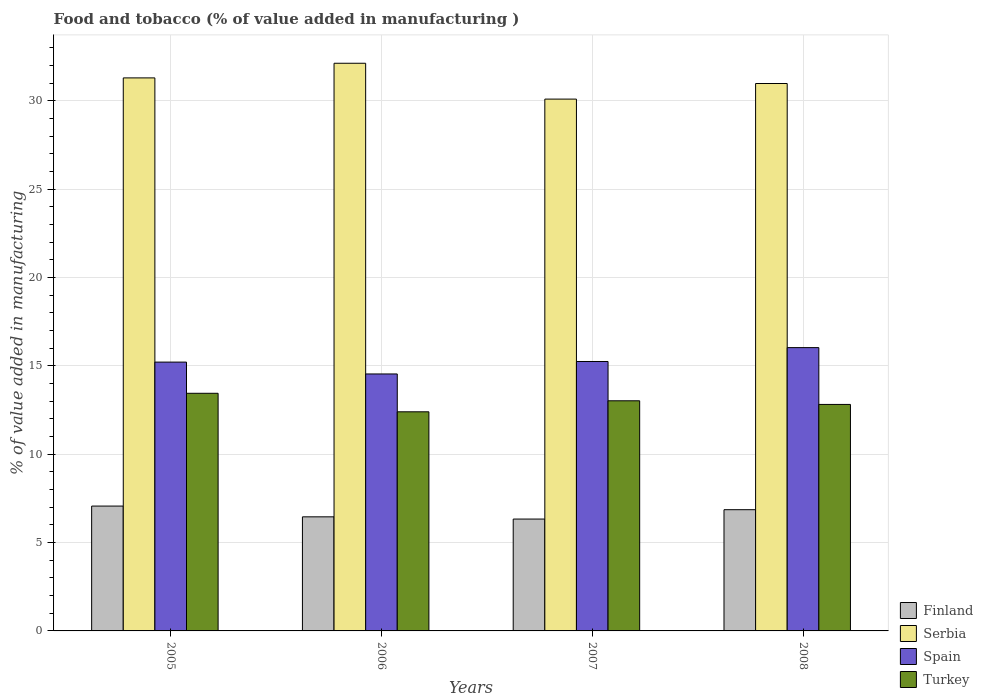Are the number of bars per tick equal to the number of legend labels?
Provide a short and direct response. Yes. Are the number of bars on each tick of the X-axis equal?
Provide a succinct answer. Yes. How many bars are there on the 2nd tick from the left?
Your response must be concise. 4. How many bars are there on the 1st tick from the right?
Keep it short and to the point. 4. What is the value added in manufacturing food and tobacco in Turkey in 2007?
Offer a terse response. 13.02. Across all years, what is the maximum value added in manufacturing food and tobacco in Turkey?
Provide a succinct answer. 13.45. Across all years, what is the minimum value added in manufacturing food and tobacco in Spain?
Your response must be concise. 14.54. In which year was the value added in manufacturing food and tobacco in Finland maximum?
Your answer should be compact. 2005. What is the total value added in manufacturing food and tobacco in Turkey in the graph?
Offer a very short reply. 51.68. What is the difference between the value added in manufacturing food and tobacco in Serbia in 2006 and that in 2008?
Give a very brief answer. 1.15. What is the difference between the value added in manufacturing food and tobacco in Spain in 2008 and the value added in manufacturing food and tobacco in Finland in 2006?
Ensure brevity in your answer.  9.57. What is the average value added in manufacturing food and tobacco in Spain per year?
Your answer should be very brief. 15.26. In the year 2005, what is the difference between the value added in manufacturing food and tobacco in Turkey and value added in manufacturing food and tobacco in Spain?
Ensure brevity in your answer.  -1.76. In how many years, is the value added in manufacturing food and tobacco in Serbia greater than 1 %?
Your answer should be very brief. 4. What is the ratio of the value added in manufacturing food and tobacco in Finland in 2006 to that in 2007?
Your answer should be compact. 1.02. Is the value added in manufacturing food and tobacco in Serbia in 2006 less than that in 2007?
Your answer should be very brief. No. What is the difference between the highest and the second highest value added in manufacturing food and tobacco in Turkey?
Offer a terse response. 0.42. What is the difference between the highest and the lowest value added in manufacturing food and tobacco in Serbia?
Offer a terse response. 2.03. What does the 2nd bar from the left in 2007 represents?
Keep it short and to the point. Serbia. Is it the case that in every year, the sum of the value added in manufacturing food and tobacco in Finland and value added in manufacturing food and tobacco in Turkey is greater than the value added in manufacturing food and tobacco in Spain?
Make the answer very short. Yes. Are all the bars in the graph horizontal?
Provide a succinct answer. No. How many years are there in the graph?
Your answer should be compact. 4. Does the graph contain any zero values?
Keep it short and to the point. No. Does the graph contain grids?
Your answer should be compact. Yes. Where does the legend appear in the graph?
Your response must be concise. Bottom right. How many legend labels are there?
Provide a short and direct response. 4. How are the legend labels stacked?
Your response must be concise. Vertical. What is the title of the graph?
Offer a very short reply. Food and tobacco (% of value added in manufacturing ). Does "Cameroon" appear as one of the legend labels in the graph?
Your response must be concise. No. What is the label or title of the Y-axis?
Provide a short and direct response. % of value added in manufacturing. What is the % of value added in manufacturing of Finland in 2005?
Make the answer very short. 7.06. What is the % of value added in manufacturing in Serbia in 2005?
Your answer should be very brief. 31.29. What is the % of value added in manufacturing in Spain in 2005?
Offer a terse response. 15.21. What is the % of value added in manufacturing in Turkey in 2005?
Provide a short and direct response. 13.45. What is the % of value added in manufacturing in Finland in 2006?
Provide a short and direct response. 6.46. What is the % of value added in manufacturing in Serbia in 2006?
Ensure brevity in your answer.  32.12. What is the % of value added in manufacturing of Spain in 2006?
Your response must be concise. 14.54. What is the % of value added in manufacturing in Turkey in 2006?
Offer a terse response. 12.4. What is the % of value added in manufacturing in Finland in 2007?
Give a very brief answer. 6.33. What is the % of value added in manufacturing in Serbia in 2007?
Provide a short and direct response. 30.09. What is the % of value added in manufacturing of Spain in 2007?
Keep it short and to the point. 15.25. What is the % of value added in manufacturing of Turkey in 2007?
Make the answer very short. 13.02. What is the % of value added in manufacturing of Finland in 2008?
Provide a short and direct response. 6.86. What is the % of value added in manufacturing in Serbia in 2008?
Provide a short and direct response. 30.97. What is the % of value added in manufacturing in Spain in 2008?
Ensure brevity in your answer.  16.03. What is the % of value added in manufacturing in Turkey in 2008?
Give a very brief answer. 12.82. Across all years, what is the maximum % of value added in manufacturing in Finland?
Provide a short and direct response. 7.06. Across all years, what is the maximum % of value added in manufacturing of Serbia?
Your response must be concise. 32.12. Across all years, what is the maximum % of value added in manufacturing of Spain?
Your response must be concise. 16.03. Across all years, what is the maximum % of value added in manufacturing in Turkey?
Your response must be concise. 13.45. Across all years, what is the minimum % of value added in manufacturing of Finland?
Make the answer very short. 6.33. Across all years, what is the minimum % of value added in manufacturing of Serbia?
Make the answer very short. 30.09. Across all years, what is the minimum % of value added in manufacturing in Spain?
Ensure brevity in your answer.  14.54. Across all years, what is the minimum % of value added in manufacturing of Turkey?
Your answer should be very brief. 12.4. What is the total % of value added in manufacturing in Finland in the graph?
Offer a terse response. 26.71. What is the total % of value added in manufacturing in Serbia in the graph?
Offer a very short reply. 124.48. What is the total % of value added in manufacturing of Spain in the graph?
Provide a succinct answer. 61.03. What is the total % of value added in manufacturing of Turkey in the graph?
Keep it short and to the point. 51.68. What is the difference between the % of value added in manufacturing in Finland in 2005 and that in 2006?
Your response must be concise. 0.61. What is the difference between the % of value added in manufacturing of Serbia in 2005 and that in 2006?
Keep it short and to the point. -0.83. What is the difference between the % of value added in manufacturing in Spain in 2005 and that in 2006?
Give a very brief answer. 0.67. What is the difference between the % of value added in manufacturing of Turkey in 2005 and that in 2006?
Keep it short and to the point. 1.05. What is the difference between the % of value added in manufacturing of Finland in 2005 and that in 2007?
Provide a succinct answer. 0.74. What is the difference between the % of value added in manufacturing of Serbia in 2005 and that in 2007?
Give a very brief answer. 1.2. What is the difference between the % of value added in manufacturing in Spain in 2005 and that in 2007?
Keep it short and to the point. -0.03. What is the difference between the % of value added in manufacturing of Turkey in 2005 and that in 2007?
Your answer should be very brief. 0.42. What is the difference between the % of value added in manufacturing of Finland in 2005 and that in 2008?
Keep it short and to the point. 0.21. What is the difference between the % of value added in manufacturing of Serbia in 2005 and that in 2008?
Your answer should be very brief. 0.32. What is the difference between the % of value added in manufacturing of Spain in 2005 and that in 2008?
Your answer should be very brief. -0.82. What is the difference between the % of value added in manufacturing of Turkey in 2005 and that in 2008?
Your answer should be compact. 0.63. What is the difference between the % of value added in manufacturing in Finland in 2006 and that in 2007?
Provide a succinct answer. 0.13. What is the difference between the % of value added in manufacturing of Serbia in 2006 and that in 2007?
Provide a succinct answer. 2.03. What is the difference between the % of value added in manufacturing of Spain in 2006 and that in 2007?
Make the answer very short. -0.7. What is the difference between the % of value added in manufacturing in Turkey in 2006 and that in 2007?
Provide a succinct answer. -0.62. What is the difference between the % of value added in manufacturing in Finland in 2006 and that in 2008?
Provide a short and direct response. -0.4. What is the difference between the % of value added in manufacturing of Serbia in 2006 and that in 2008?
Make the answer very short. 1.15. What is the difference between the % of value added in manufacturing in Spain in 2006 and that in 2008?
Your response must be concise. -1.49. What is the difference between the % of value added in manufacturing in Turkey in 2006 and that in 2008?
Offer a very short reply. -0.42. What is the difference between the % of value added in manufacturing in Finland in 2007 and that in 2008?
Offer a terse response. -0.53. What is the difference between the % of value added in manufacturing of Serbia in 2007 and that in 2008?
Your response must be concise. -0.88. What is the difference between the % of value added in manufacturing of Spain in 2007 and that in 2008?
Offer a very short reply. -0.79. What is the difference between the % of value added in manufacturing of Turkey in 2007 and that in 2008?
Your response must be concise. 0.21. What is the difference between the % of value added in manufacturing of Finland in 2005 and the % of value added in manufacturing of Serbia in 2006?
Your response must be concise. -25.06. What is the difference between the % of value added in manufacturing of Finland in 2005 and the % of value added in manufacturing of Spain in 2006?
Give a very brief answer. -7.48. What is the difference between the % of value added in manufacturing in Finland in 2005 and the % of value added in manufacturing in Turkey in 2006?
Your response must be concise. -5.33. What is the difference between the % of value added in manufacturing in Serbia in 2005 and the % of value added in manufacturing in Spain in 2006?
Provide a short and direct response. 16.75. What is the difference between the % of value added in manufacturing of Serbia in 2005 and the % of value added in manufacturing of Turkey in 2006?
Ensure brevity in your answer.  18.89. What is the difference between the % of value added in manufacturing of Spain in 2005 and the % of value added in manufacturing of Turkey in 2006?
Give a very brief answer. 2.81. What is the difference between the % of value added in manufacturing in Finland in 2005 and the % of value added in manufacturing in Serbia in 2007?
Provide a succinct answer. -23.03. What is the difference between the % of value added in manufacturing of Finland in 2005 and the % of value added in manufacturing of Spain in 2007?
Your response must be concise. -8.18. What is the difference between the % of value added in manufacturing in Finland in 2005 and the % of value added in manufacturing in Turkey in 2007?
Your answer should be very brief. -5.96. What is the difference between the % of value added in manufacturing of Serbia in 2005 and the % of value added in manufacturing of Spain in 2007?
Keep it short and to the point. 16.05. What is the difference between the % of value added in manufacturing of Serbia in 2005 and the % of value added in manufacturing of Turkey in 2007?
Ensure brevity in your answer.  18.27. What is the difference between the % of value added in manufacturing in Spain in 2005 and the % of value added in manufacturing in Turkey in 2007?
Make the answer very short. 2.19. What is the difference between the % of value added in manufacturing of Finland in 2005 and the % of value added in manufacturing of Serbia in 2008?
Provide a succinct answer. -23.91. What is the difference between the % of value added in manufacturing of Finland in 2005 and the % of value added in manufacturing of Spain in 2008?
Ensure brevity in your answer.  -8.97. What is the difference between the % of value added in manufacturing in Finland in 2005 and the % of value added in manufacturing in Turkey in 2008?
Offer a very short reply. -5.75. What is the difference between the % of value added in manufacturing in Serbia in 2005 and the % of value added in manufacturing in Spain in 2008?
Ensure brevity in your answer.  15.26. What is the difference between the % of value added in manufacturing in Serbia in 2005 and the % of value added in manufacturing in Turkey in 2008?
Your response must be concise. 18.48. What is the difference between the % of value added in manufacturing of Spain in 2005 and the % of value added in manufacturing of Turkey in 2008?
Offer a very short reply. 2.39. What is the difference between the % of value added in manufacturing of Finland in 2006 and the % of value added in manufacturing of Serbia in 2007?
Provide a short and direct response. -23.64. What is the difference between the % of value added in manufacturing in Finland in 2006 and the % of value added in manufacturing in Spain in 2007?
Offer a very short reply. -8.79. What is the difference between the % of value added in manufacturing in Finland in 2006 and the % of value added in manufacturing in Turkey in 2007?
Offer a very short reply. -6.57. What is the difference between the % of value added in manufacturing of Serbia in 2006 and the % of value added in manufacturing of Spain in 2007?
Your answer should be very brief. 16.88. What is the difference between the % of value added in manufacturing of Serbia in 2006 and the % of value added in manufacturing of Turkey in 2007?
Ensure brevity in your answer.  19.1. What is the difference between the % of value added in manufacturing of Spain in 2006 and the % of value added in manufacturing of Turkey in 2007?
Give a very brief answer. 1.52. What is the difference between the % of value added in manufacturing of Finland in 2006 and the % of value added in manufacturing of Serbia in 2008?
Make the answer very short. -24.52. What is the difference between the % of value added in manufacturing in Finland in 2006 and the % of value added in manufacturing in Spain in 2008?
Keep it short and to the point. -9.57. What is the difference between the % of value added in manufacturing in Finland in 2006 and the % of value added in manufacturing in Turkey in 2008?
Your response must be concise. -6.36. What is the difference between the % of value added in manufacturing in Serbia in 2006 and the % of value added in manufacturing in Spain in 2008?
Ensure brevity in your answer.  16.09. What is the difference between the % of value added in manufacturing in Serbia in 2006 and the % of value added in manufacturing in Turkey in 2008?
Your response must be concise. 19.3. What is the difference between the % of value added in manufacturing of Spain in 2006 and the % of value added in manufacturing of Turkey in 2008?
Your answer should be compact. 1.72. What is the difference between the % of value added in manufacturing of Finland in 2007 and the % of value added in manufacturing of Serbia in 2008?
Offer a terse response. -24.64. What is the difference between the % of value added in manufacturing of Finland in 2007 and the % of value added in manufacturing of Spain in 2008?
Keep it short and to the point. -9.7. What is the difference between the % of value added in manufacturing in Finland in 2007 and the % of value added in manufacturing in Turkey in 2008?
Your answer should be very brief. -6.49. What is the difference between the % of value added in manufacturing in Serbia in 2007 and the % of value added in manufacturing in Spain in 2008?
Your answer should be very brief. 14.06. What is the difference between the % of value added in manufacturing in Serbia in 2007 and the % of value added in manufacturing in Turkey in 2008?
Your answer should be very brief. 17.28. What is the difference between the % of value added in manufacturing of Spain in 2007 and the % of value added in manufacturing of Turkey in 2008?
Provide a short and direct response. 2.43. What is the average % of value added in manufacturing in Finland per year?
Offer a very short reply. 6.68. What is the average % of value added in manufacturing in Serbia per year?
Provide a succinct answer. 31.12. What is the average % of value added in manufacturing in Spain per year?
Offer a terse response. 15.26. What is the average % of value added in manufacturing of Turkey per year?
Your answer should be very brief. 12.92. In the year 2005, what is the difference between the % of value added in manufacturing in Finland and % of value added in manufacturing in Serbia?
Make the answer very short. -24.23. In the year 2005, what is the difference between the % of value added in manufacturing of Finland and % of value added in manufacturing of Spain?
Your answer should be very brief. -8.15. In the year 2005, what is the difference between the % of value added in manufacturing of Finland and % of value added in manufacturing of Turkey?
Keep it short and to the point. -6.38. In the year 2005, what is the difference between the % of value added in manufacturing of Serbia and % of value added in manufacturing of Spain?
Keep it short and to the point. 16.08. In the year 2005, what is the difference between the % of value added in manufacturing of Serbia and % of value added in manufacturing of Turkey?
Offer a very short reply. 17.85. In the year 2005, what is the difference between the % of value added in manufacturing in Spain and % of value added in manufacturing in Turkey?
Keep it short and to the point. 1.76. In the year 2006, what is the difference between the % of value added in manufacturing of Finland and % of value added in manufacturing of Serbia?
Your answer should be compact. -25.66. In the year 2006, what is the difference between the % of value added in manufacturing of Finland and % of value added in manufacturing of Spain?
Offer a terse response. -8.08. In the year 2006, what is the difference between the % of value added in manufacturing of Finland and % of value added in manufacturing of Turkey?
Your answer should be very brief. -5.94. In the year 2006, what is the difference between the % of value added in manufacturing of Serbia and % of value added in manufacturing of Spain?
Give a very brief answer. 17.58. In the year 2006, what is the difference between the % of value added in manufacturing of Serbia and % of value added in manufacturing of Turkey?
Your answer should be compact. 19.72. In the year 2006, what is the difference between the % of value added in manufacturing of Spain and % of value added in manufacturing of Turkey?
Your answer should be compact. 2.14. In the year 2007, what is the difference between the % of value added in manufacturing in Finland and % of value added in manufacturing in Serbia?
Your response must be concise. -23.76. In the year 2007, what is the difference between the % of value added in manufacturing of Finland and % of value added in manufacturing of Spain?
Ensure brevity in your answer.  -8.92. In the year 2007, what is the difference between the % of value added in manufacturing in Finland and % of value added in manufacturing in Turkey?
Provide a succinct answer. -6.69. In the year 2007, what is the difference between the % of value added in manufacturing of Serbia and % of value added in manufacturing of Spain?
Ensure brevity in your answer.  14.85. In the year 2007, what is the difference between the % of value added in manufacturing in Serbia and % of value added in manufacturing in Turkey?
Your response must be concise. 17.07. In the year 2007, what is the difference between the % of value added in manufacturing in Spain and % of value added in manufacturing in Turkey?
Ensure brevity in your answer.  2.22. In the year 2008, what is the difference between the % of value added in manufacturing of Finland and % of value added in manufacturing of Serbia?
Make the answer very short. -24.12. In the year 2008, what is the difference between the % of value added in manufacturing in Finland and % of value added in manufacturing in Spain?
Make the answer very short. -9.17. In the year 2008, what is the difference between the % of value added in manufacturing in Finland and % of value added in manufacturing in Turkey?
Provide a succinct answer. -5.96. In the year 2008, what is the difference between the % of value added in manufacturing in Serbia and % of value added in manufacturing in Spain?
Make the answer very short. 14.94. In the year 2008, what is the difference between the % of value added in manufacturing of Serbia and % of value added in manufacturing of Turkey?
Your answer should be very brief. 18.16. In the year 2008, what is the difference between the % of value added in manufacturing of Spain and % of value added in manufacturing of Turkey?
Ensure brevity in your answer.  3.21. What is the ratio of the % of value added in manufacturing of Finland in 2005 to that in 2006?
Provide a succinct answer. 1.09. What is the ratio of the % of value added in manufacturing of Serbia in 2005 to that in 2006?
Your response must be concise. 0.97. What is the ratio of the % of value added in manufacturing in Spain in 2005 to that in 2006?
Your answer should be compact. 1.05. What is the ratio of the % of value added in manufacturing in Turkey in 2005 to that in 2006?
Ensure brevity in your answer.  1.08. What is the ratio of the % of value added in manufacturing in Finland in 2005 to that in 2007?
Ensure brevity in your answer.  1.12. What is the ratio of the % of value added in manufacturing of Serbia in 2005 to that in 2007?
Keep it short and to the point. 1.04. What is the ratio of the % of value added in manufacturing in Turkey in 2005 to that in 2007?
Offer a terse response. 1.03. What is the ratio of the % of value added in manufacturing in Serbia in 2005 to that in 2008?
Offer a terse response. 1.01. What is the ratio of the % of value added in manufacturing of Spain in 2005 to that in 2008?
Provide a short and direct response. 0.95. What is the ratio of the % of value added in manufacturing of Turkey in 2005 to that in 2008?
Make the answer very short. 1.05. What is the ratio of the % of value added in manufacturing of Finland in 2006 to that in 2007?
Provide a succinct answer. 1.02. What is the ratio of the % of value added in manufacturing of Serbia in 2006 to that in 2007?
Give a very brief answer. 1.07. What is the ratio of the % of value added in manufacturing in Spain in 2006 to that in 2007?
Offer a very short reply. 0.95. What is the ratio of the % of value added in manufacturing in Turkey in 2006 to that in 2007?
Keep it short and to the point. 0.95. What is the ratio of the % of value added in manufacturing of Serbia in 2006 to that in 2008?
Offer a terse response. 1.04. What is the ratio of the % of value added in manufacturing in Spain in 2006 to that in 2008?
Give a very brief answer. 0.91. What is the ratio of the % of value added in manufacturing in Turkey in 2006 to that in 2008?
Provide a short and direct response. 0.97. What is the ratio of the % of value added in manufacturing in Finland in 2007 to that in 2008?
Keep it short and to the point. 0.92. What is the ratio of the % of value added in manufacturing in Serbia in 2007 to that in 2008?
Make the answer very short. 0.97. What is the ratio of the % of value added in manufacturing in Spain in 2007 to that in 2008?
Provide a succinct answer. 0.95. What is the ratio of the % of value added in manufacturing in Turkey in 2007 to that in 2008?
Provide a succinct answer. 1.02. What is the difference between the highest and the second highest % of value added in manufacturing in Finland?
Your response must be concise. 0.21. What is the difference between the highest and the second highest % of value added in manufacturing in Serbia?
Keep it short and to the point. 0.83. What is the difference between the highest and the second highest % of value added in manufacturing in Spain?
Your answer should be compact. 0.79. What is the difference between the highest and the second highest % of value added in manufacturing in Turkey?
Your answer should be very brief. 0.42. What is the difference between the highest and the lowest % of value added in manufacturing of Finland?
Give a very brief answer. 0.74. What is the difference between the highest and the lowest % of value added in manufacturing in Serbia?
Your response must be concise. 2.03. What is the difference between the highest and the lowest % of value added in manufacturing in Spain?
Your response must be concise. 1.49. What is the difference between the highest and the lowest % of value added in manufacturing in Turkey?
Offer a terse response. 1.05. 